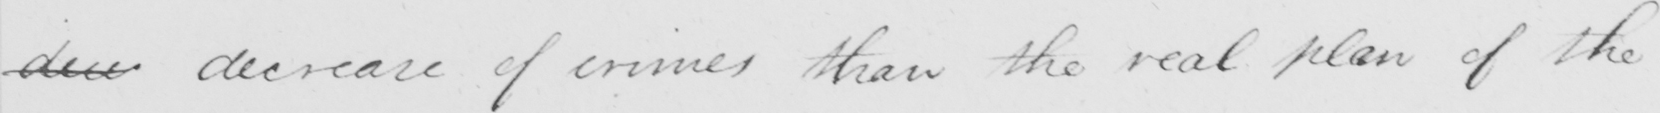What text is written in this handwritten line? dicr decrease of crimes than the real plan of the 